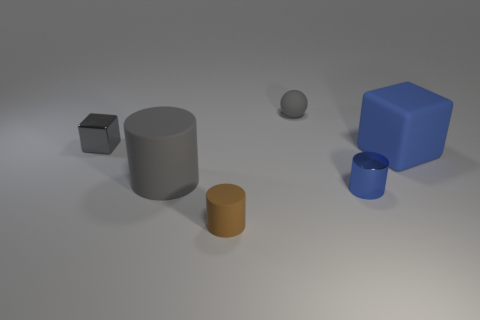Is the number of gray spheres left of the large gray object greater than the number of large yellow metallic spheres?
Keep it short and to the point. No. There is a tiny shiny object in front of the big cylinder; is it the same shape as the gray metal object?
Offer a terse response. No. How many purple things are large rubber cylinders or rubber cylinders?
Your response must be concise. 0. Are there more large cyan shiny cubes than big gray matte objects?
Offer a very short reply. No. What color is the metallic cylinder that is the same size as the rubber sphere?
Your answer should be compact. Blue. What number of cubes are either small red metal things or brown rubber objects?
Offer a very short reply. 0. There is a tiny blue metallic object; does it have the same shape as the small metallic object that is left of the gray rubber ball?
Your response must be concise. No. What number of blocks have the same size as the brown object?
Ensure brevity in your answer.  1. There is a tiny matte object on the right side of the brown rubber object; is it the same shape as the metal thing that is left of the large gray rubber cylinder?
Keep it short and to the point. No. There is a small rubber object that is the same color as the big matte cylinder; what shape is it?
Your response must be concise. Sphere. 